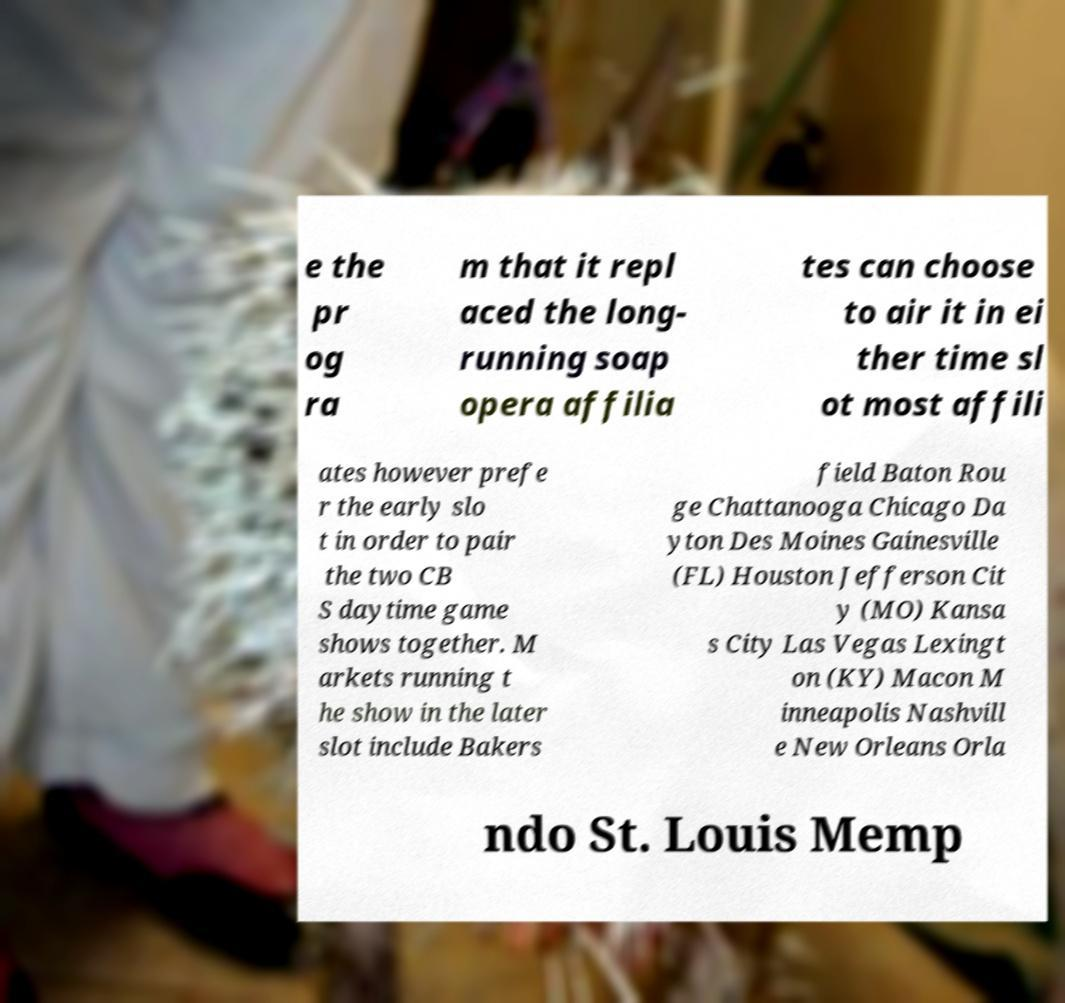There's text embedded in this image that I need extracted. Can you transcribe it verbatim? e the pr og ra m that it repl aced the long- running soap opera affilia tes can choose to air it in ei ther time sl ot most affili ates however prefe r the early slo t in order to pair the two CB S daytime game shows together. M arkets running t he show in the later slot include Bakers field Baton Rou ge Chattanooga Chicago Da yton Des Moines Gainesville (FL) Houston Jefferson Cit y (MO) Kansa s City Las Vegas Lexingt on (KY) Macon M inneapolis Nashvill e New Orleans Orla ndo St. Louis Memp 